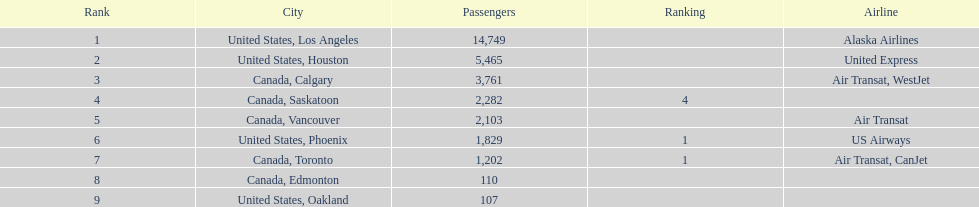Los angeles and which other city had approximately 19,000 passengers combined? Canada, Calgary. 